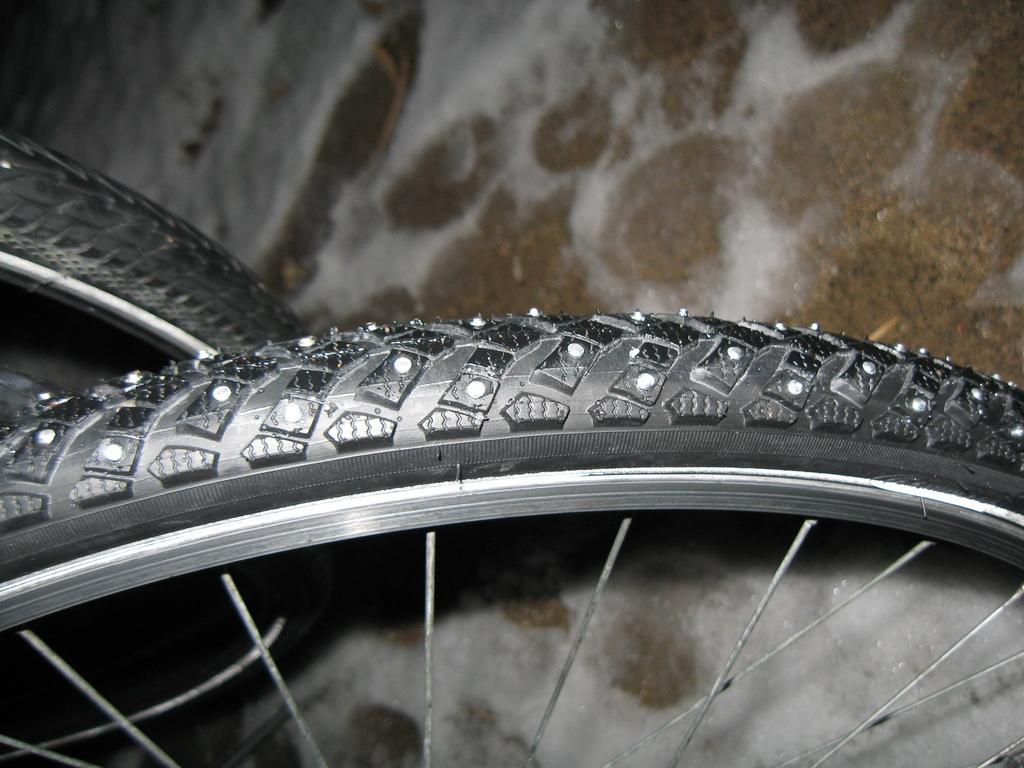Please provide a concise description of this image. In this image I can see two bicycle wheels. We can see black color tiers. 